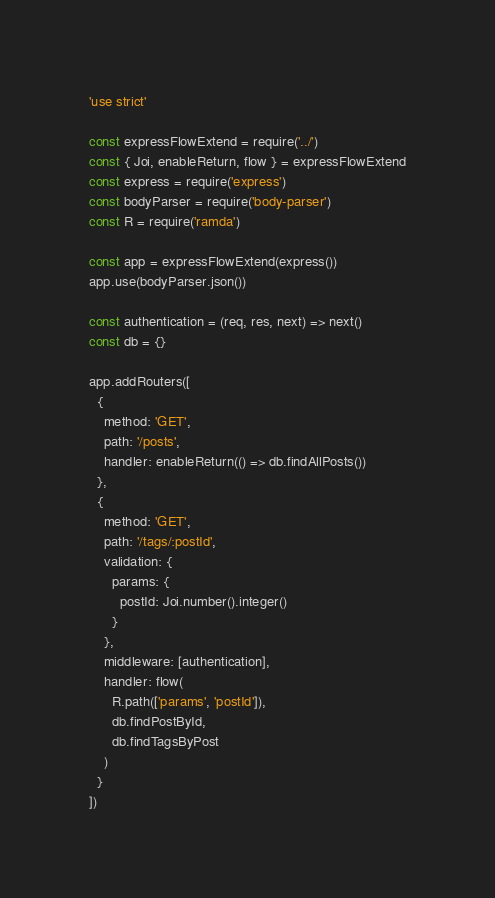<code> <loc_0><loc_0><loc_500><loc_500><_JavaScript_>'use strict'

const expressFlowExtend = require('../')
const { Joi, enableReturn, flow } = expressFlowExtend
const express = require('express')
const bodyParser = require('body-parser')
const R = require('ramda')

const app = expressFlowExtend(express())
app.use(bodyParser.json())

const authentication = (req, res, next) => next()
const db = {}

app.addRouters([
  {
    method: 'GET',
    path: '/posts',
    handler: enableReturn(() => db.findAllPosts())
  },
  {
    method: 'GET',
    path: '/tags/:postId',
    validation: {
      params: {
        postId: Joi.number().integer()
      }
    },
    middleware: [authentication],
    handler: flow(
      R.path(['params', 'postId']),
      db.findPostById,
      db.findTagsByPost
    )
  }
])
</code> 